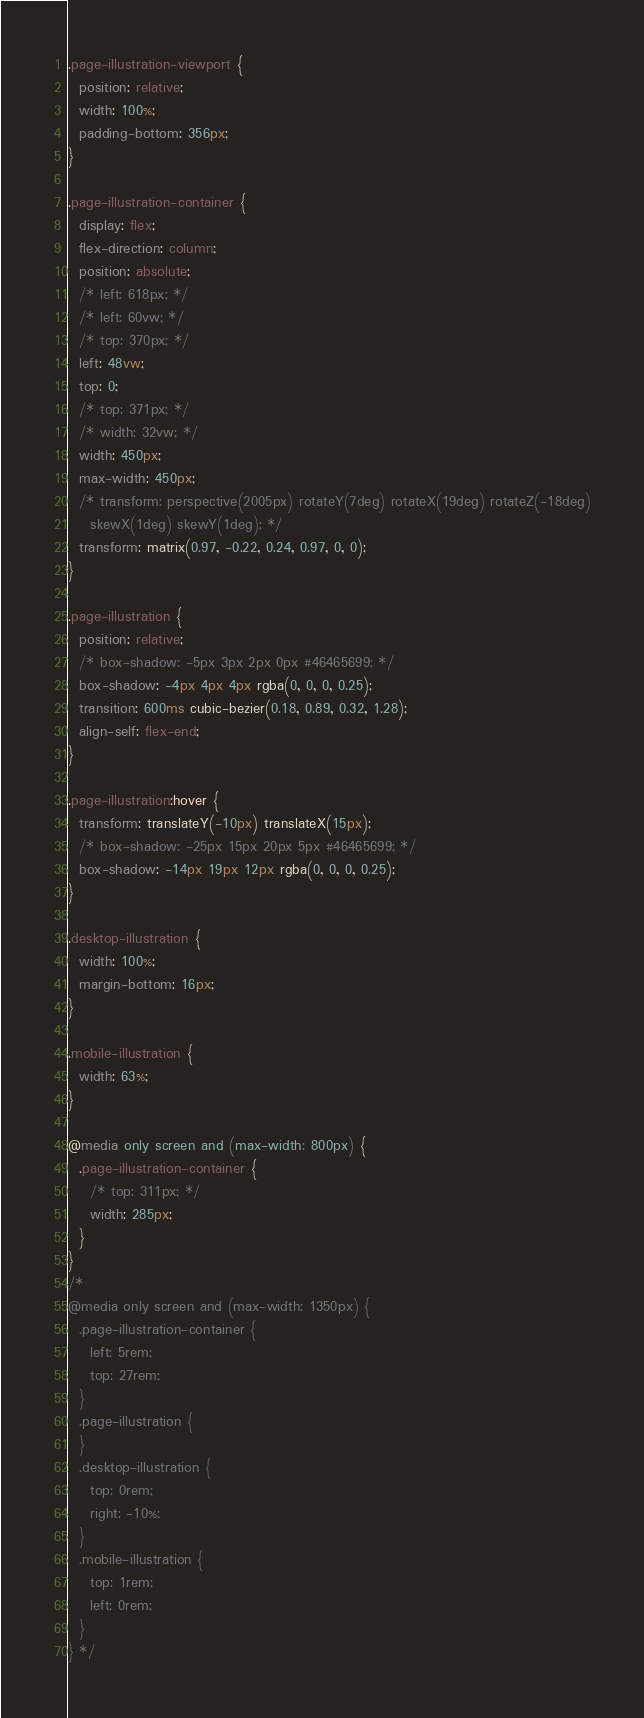Convert code to text. <code><loc_0><loc_0><loc_500><loc_500><_CSS_>.page-illustration-viewport {
  position: relative;
  width: 100%;
  padding-bottom: 356px;
}

.page-illustration-container {
  display: flex;
  flex-direction: column;
  position: absolute;
  /* left: 618px; */
  /* left: 60vw; */
  /* top: 370px; */
  left: 48vw;
  top: 0;
  /* top: 371px; */
  /* width: 32vw; */
  width: 450px;
  max-width: 450px;
  /* transform: perspective(2005px) rotateY(7deg) rotateX(19deg) rotateZ(-18deg)
    skewX(1deg) skewY(1deg); */
  transform: matrix(0.97, -0.22, 0.24, 0.97, 0, 0);
}

.page-illustration {
  position: relative;
  /* box-shadow: -5px 3px 2px 0px #46465699; */
  box-shadow: -4px 4px 4px rgba(0, 0, 0, 0.25);
  transition: 600ms cubic-bezier(0.18, 0.89, 0.32, 1.28);
  align-self: flex-end;
}

.page-illustration:hover {
  transform: translateY(-10px) translateX(15px);
  /* box-shadow: -25px 15px 20px 5px #46465699; */
  box-shadow: -14px 19px 12px rgba(0, 0, 0, 0.25);
}

.desktop-illustration {
  width: 100%;
  margin-bottom: 16px;
}

.mobile-illustration {
  width: 63%;
}

@media only screen and (max-width: 800px) {
  .page-illustration-container {
    /* top: 311px; */
    width: 285px;
  }
}
/* 
@media only screen and (max-width: 1350px) {
  .page-illustration-container {
    left: 5rem;
    top: 27rem;
  }
  .page-illustration {
  }
  .desktop-illustration {
    top: 0rem;
    right: -10%;
  }
  .mobile-illustration {
    top: 1rem;
    left: 0rem;
  }
} */
</code> 